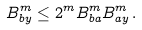<formula> <loc_0><loc_0><loc_500><loc_500>B _ { b y } ^ { m } \leq 2 ^ { m } B _ { b a } ^ { m } B _ { a y } ^ { m } \, .</formula> 